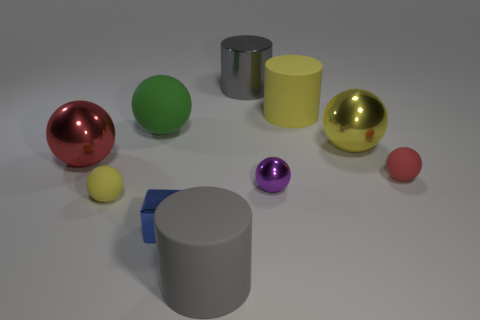There is a small metallic thing that is on the left side of the big cylinder that is behind the yellow object that is behind the big green object; what is its color?
Give a very brief answer. Blue. What number of small green rubber cubes are there?
Keep it short and to the point. 0. How many large things are either yellow objects or green rubber objects?
Your answer should be compact. 3. There is a green rubber thing that is the same size as the gray matte object; what shape is it?
Your response must be concise. Sphere. What is the material of the red object on the right side of the big gray thing in front of the yellow metallic ball?
Give a very brief answer. Rubber. Do the purple ball and the blue thing have the same size?
Provide a succinct answer. Yes. How many objects are either big metallic things that are behind the green matte sphere or tiny yellow rubber cylinders?
Provide a succinct answer. 1. There is a large red metallic object that is left of the tiny matte thing to the right of the blue object; what is its shape?
Your response must be concise. Sphere. Does the blue metal cube have the same size as the gray cylinder that is in front of the large green rubber ball?
Your answer should be compact. No. There is a small ball that is to the left of the gray rubber cylinder; what is its material?
Give a very brief answer. Rubber. 